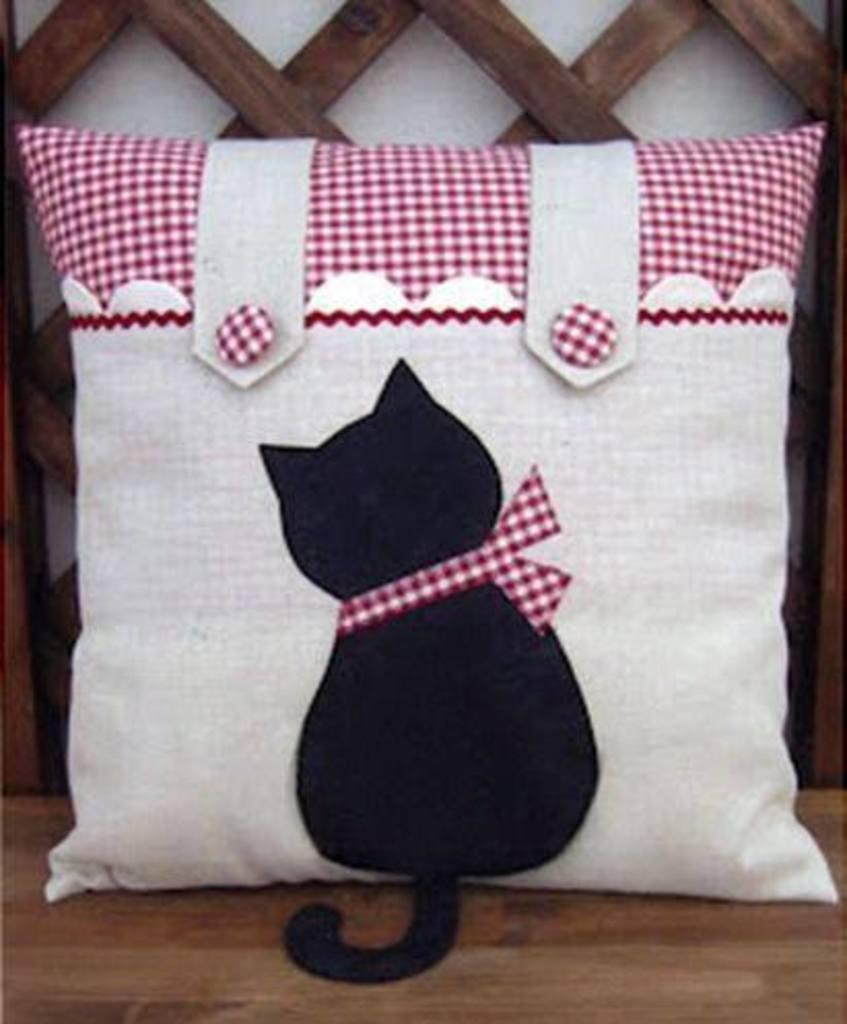How would you summarize this image in a sentence or two? In this image, we can see a pillow with an image is on the surface. In the background, we can see the wall with some wood. 